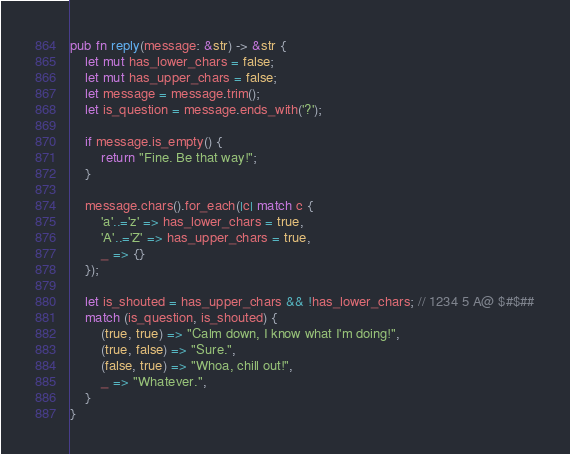<code> <loc_0><loc_0><loc_500><loc_500><_Rust_>pub fn reply(message: &str) -> &str {
    let mut has_lower_chars = false;
    let mut has_upper_chars = false;
    let message = message.trim();
    let is_question = message.ends_with('?');

    if message.is_empty() {
        return "Fine. Be that way!";
    }

    message.chars().for_each(|c| match c {
        'a'..='z' => has_lower_chars = true,
        'A'..='Z' => has_upper_chars = true,
        _ => {}
    });

    let is_shouted = has_upper_chars && !has_lower_chars; // 1234 5 A@ $#$##
    match (is_question, is_shouted) {
        (true, true) => "Calm down, I know what I'm doing!",
        (true, false) => "Sure.",
        (false, true) => "Whoa, chill out!",
        _ => "Whatever.",
    }
}
</code> 